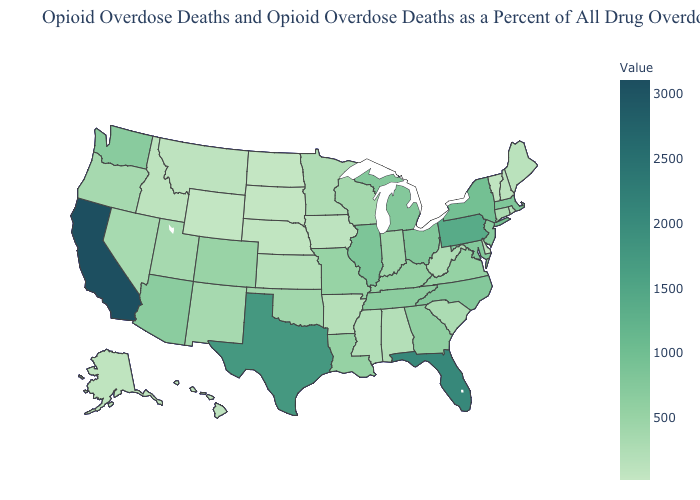Which states have the highest value in the USA?
Keep it brief. California. Which states have the lowest value in the USA?
Write a very short answer. North Dakota. Among the states that border Rhode Island , does Massachusetts have the lowest value?
Short answer required. No. Does the map have missing data?
Quick response, please. No. Among the states that border Kansas , does Colorado have the lowest value?
Give a very brief answer. No. Which states have the lowest value in the West?
Concise answer only. Wyoming. Which states hav the highest value in the Northeast?
Quick response, please. Pennsylvania. Which states have the highest value in the USA?
Write a very short answer. California. 